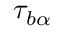<formula> <loc_0><loc_0><loc_500><loc_500>\tau _ { b \alpha }</formula> 